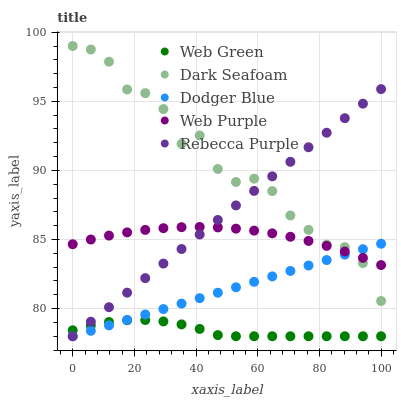Does Web Green have the minimum area under the curve?
Answer yes or no. Yes. Does Dark Seafoam have the maximum area under the curve?
Answer yes or no. Yes. Does Dodger Blue have the minimum area under the curve?
Answer yes or no. No. Does Dodger Blue have the maximum area under the curve?
Answer yes or no. No. Is Dodger Blue the smoothest?
Answer yes or no. Yes. Is Dark Seafoam the roughest?
Answer yes or no. Yes. Is Web Purple the smoothest?
Answer yes or no. No. Is Web Purple the roughest?
Answer yes or no. No. Does Dodger Blue have the lowest value?
Answer yes or no. Yes. Does Web Purple have the lowest value?
Answer yes or no. No. Does Dark Seafoam have the highest value?
Answer yes or no. Yes. Does Dodger Blue have the highest value?
Answer yes or no. No. Is Web Green less than Dark Seafoam?
Answer yes or no. Yes. Is Web Purple greater than Web Green?
Answer yes or no. Yes. Does Dodger Blue intersect Web Purple?
Answer yes or no. Yes. Is Dodger Blue less than Web Purple?
Answer yes or no. No. Is Dodger Blue greater than Web Purple?
Answer yes or no. No. Does Web Green intersect Dark Seafoam?
Answer yes or no. No. 